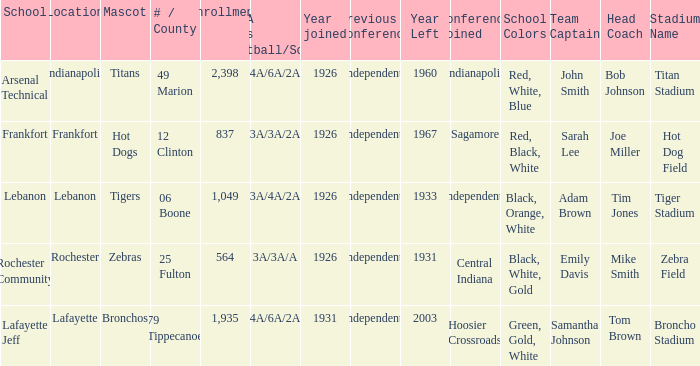What is the highest enrollment for rochester community school? 564.0. Can you give me this table as a dict? {'header': ['School', 'Location', 'Mascot', '# / County', 'Enrollment', 'IHSAA Class /Football/Soccer', 'Year joined', 'Previous Conference', 'Year Left', 'Conference Joined', 'School Colors', 'Team Captain', 'Head Coach', 'Stadium Name'], 'rows': [['Arsenal Technical', 'Indianapolis', 'Titans', '49 Marion', '2,398', '4A/6A/2A', '1926', 'Independents', '1960', 'Indianapolis', 'Red, White, Blue', 'John Smith', 'Bob Johnson', 'Titan Stadium'], ['Frankfort', 'Frankfort', 'Hot Dogs', '12 Clinton', '837', '3A/3A/2A', '1926', 'Independents', '1967', 'Sagamore', 'Red, Black, White', 'Sarah Lee', 'Joe Miller', 'Hot Dog Field'], ['Lebanon', 'Lebanon', 'Tigers', '06 Boone', '1,049', '3A/4A/2A', '1926', 'Independents', '1933', 'Independents', 'Black, Orange, White', 'Adam Brown', 'Tim Jones', 'Tiger Stadium'], ['Rochester Community', 'Rochester', 'Zebras', '25 Fulton', '564', '3A/3A/A', '1926', 'Independents', '1931', 'Central Indiana', 'Black, White, Gold', 'Emily Davis', 'Mike Smith', 'Zebra Field'], ['Lafayette Jeff', 'Lafayette', 'Bronchos', '79 Tippecanoe', '1,935', '4A/6A/2A', '1931', 'Independents', '2003', 'Hoosier Crossroads', 'Green, Gold, White', 'Samantha Johnson', 'Tom Brown', 'Broncho Stadium']]} 